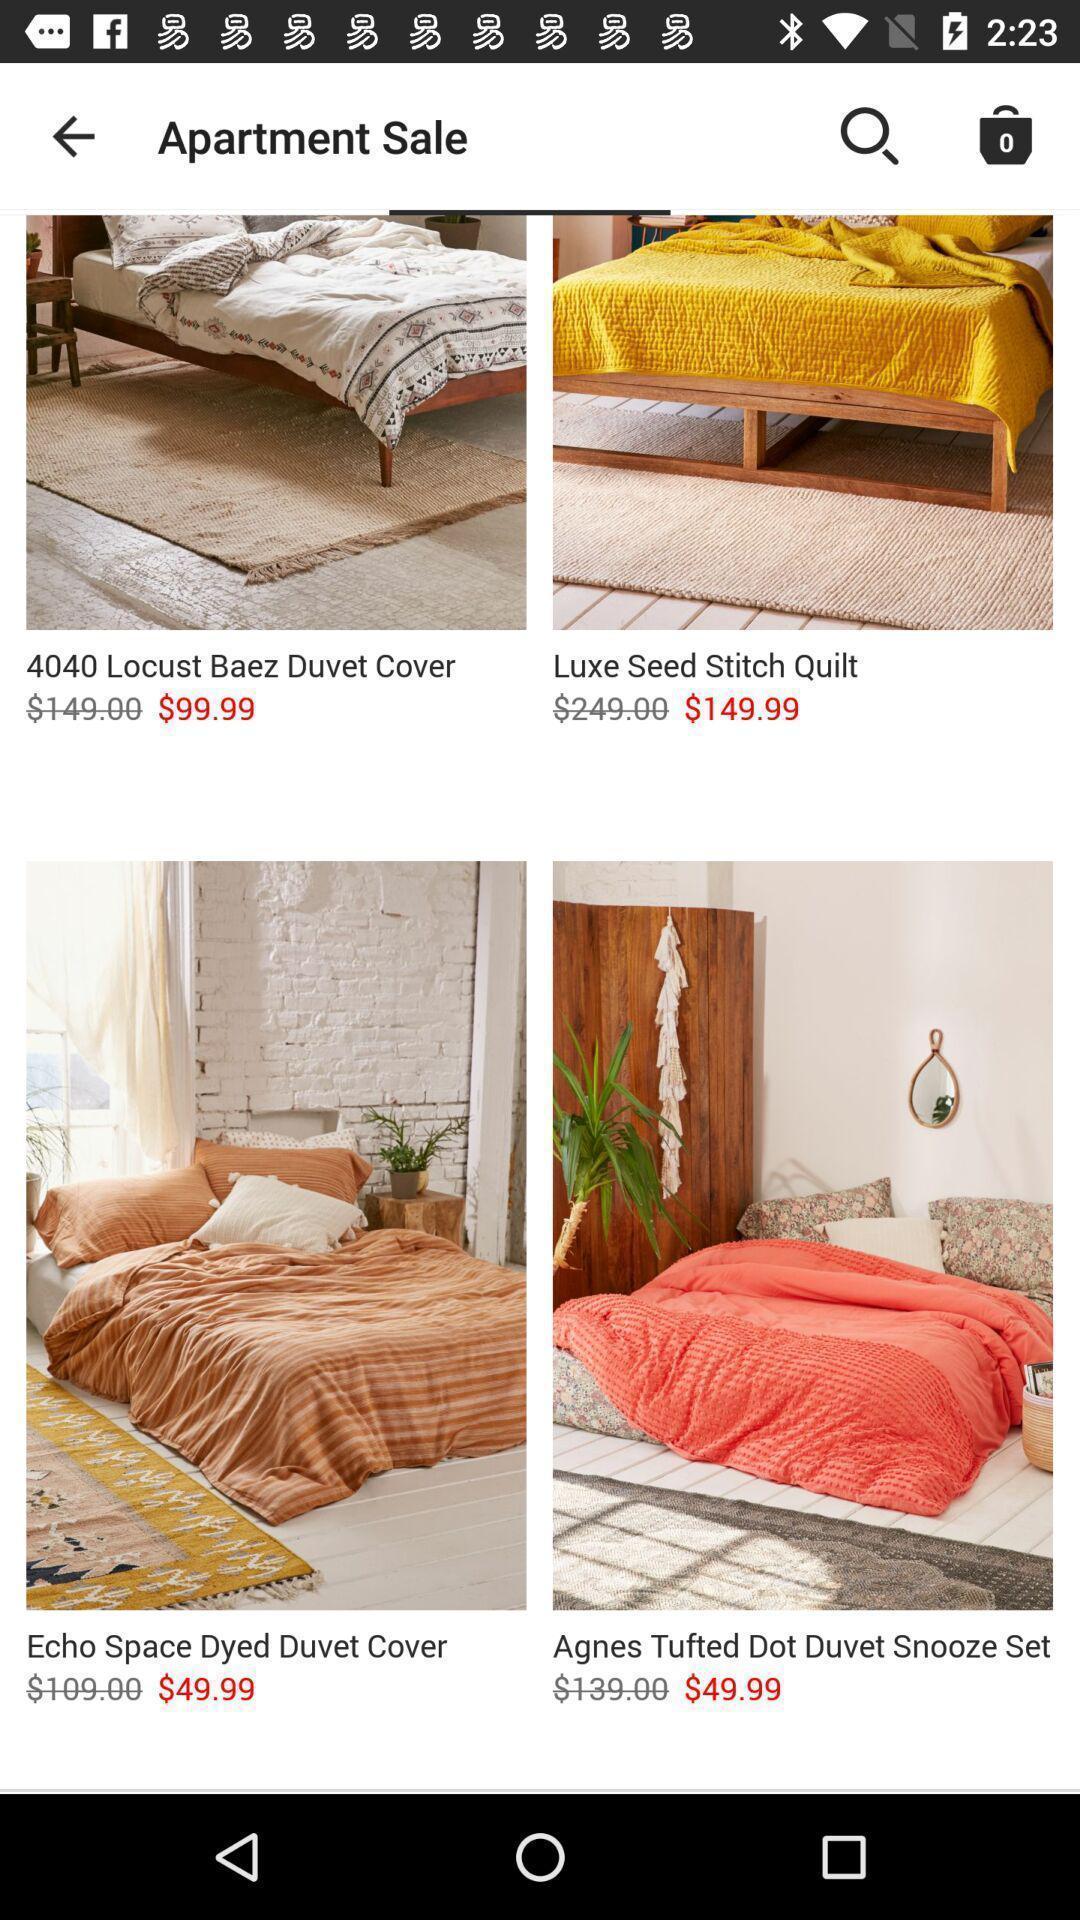What can you discern from this picture? Page displaying various items. 